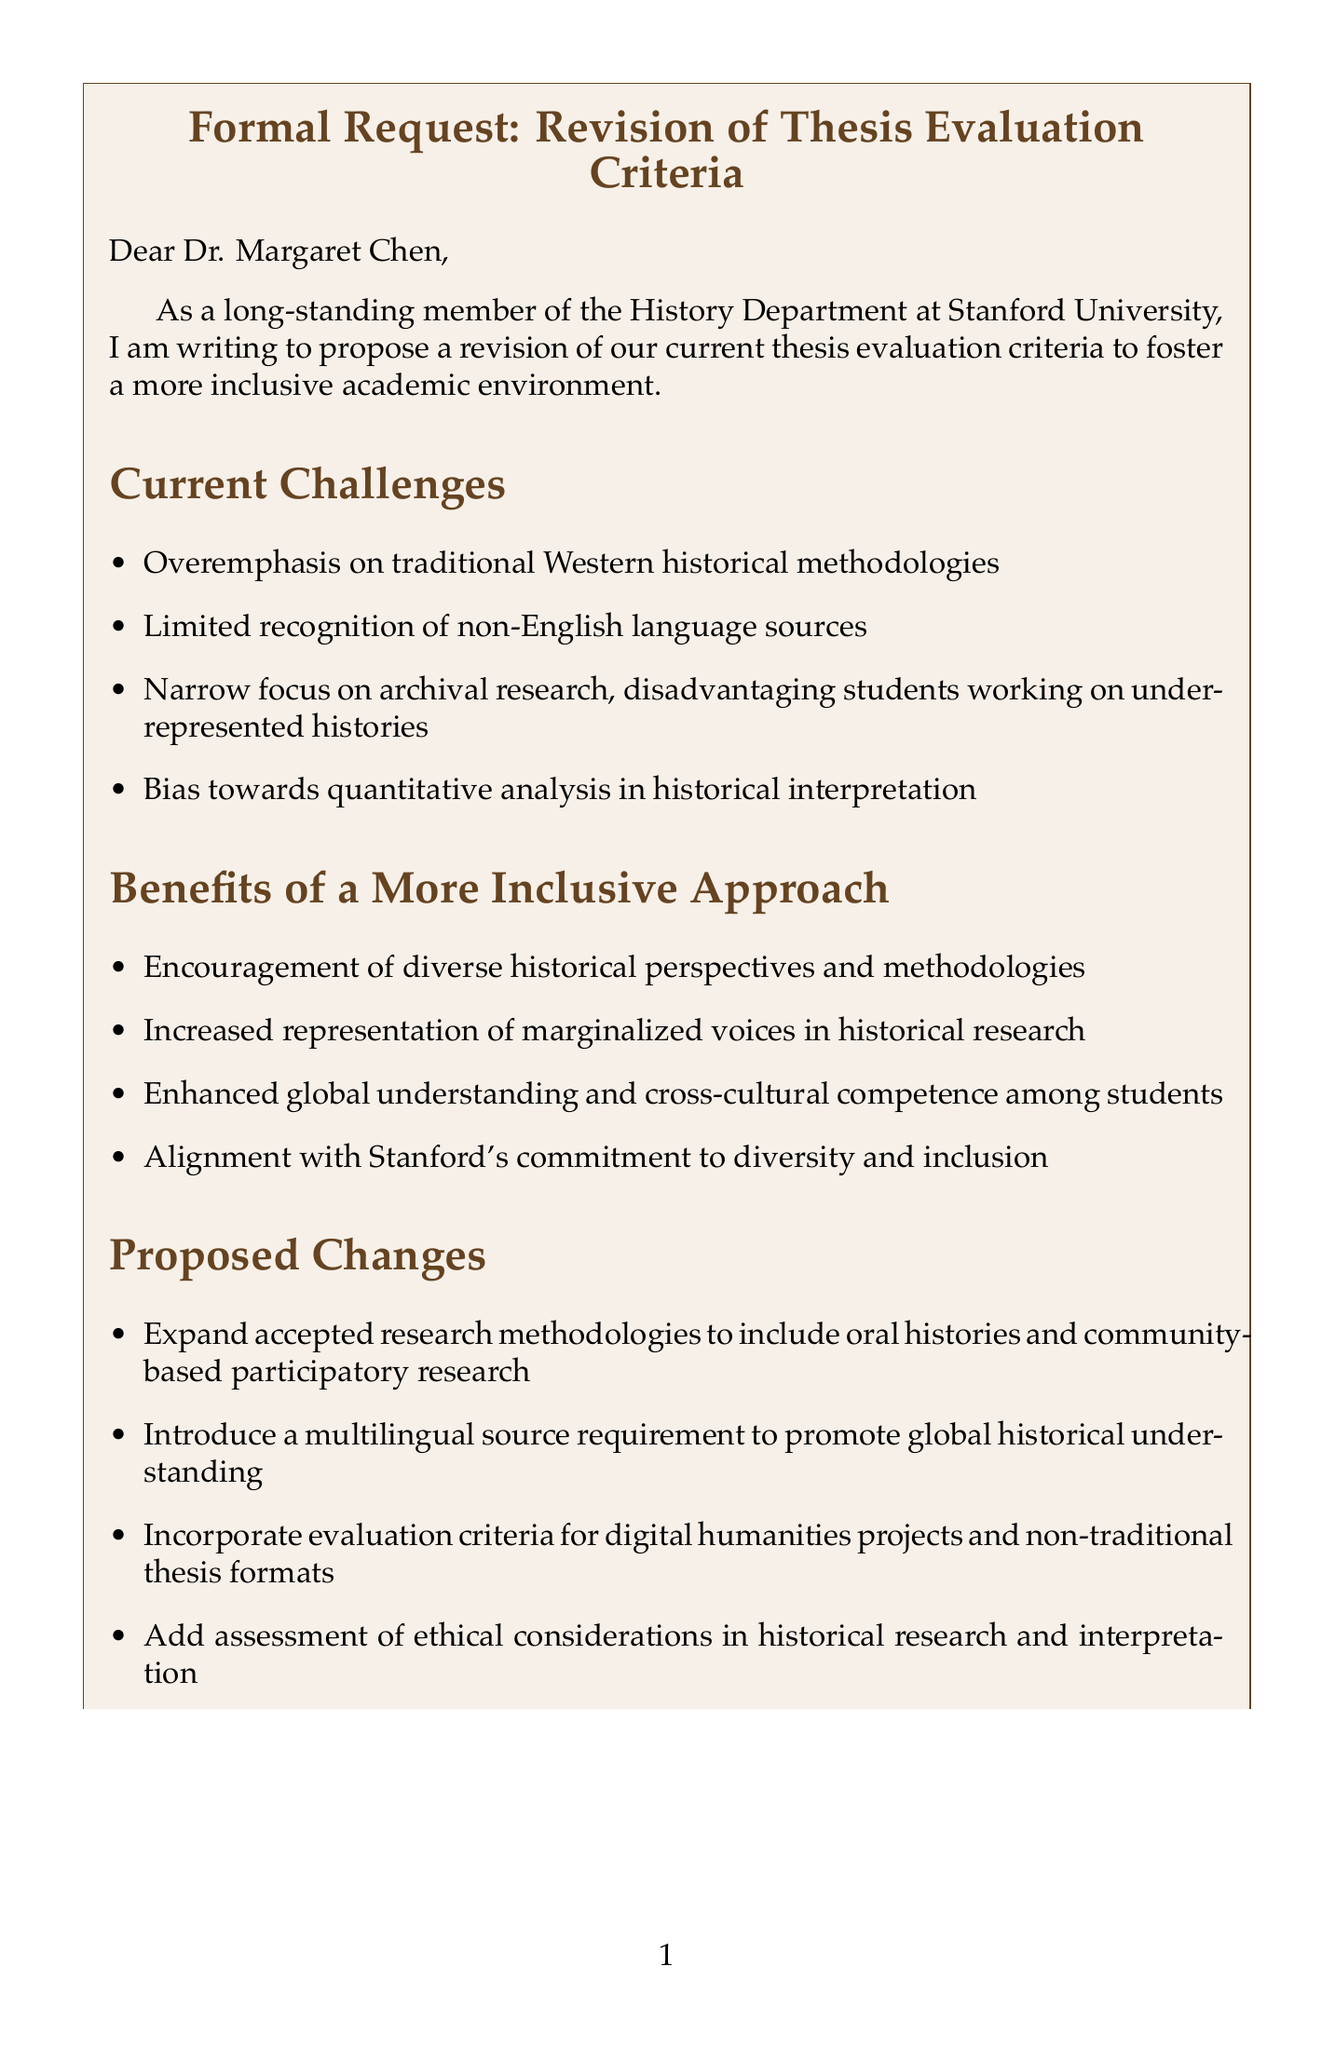What is the salutation of the letter? The salutation introduces the recipient of the letter and is often a formal greeting, in this case it is directed to Dr. Margaret Chen.
Answer: Dear Dr. Margaret Chen, What is one challenge mentioned in the current evaluation criteria? The document lists specific current challenges, one of which points out the overemphasis on a certain type of historical methodology.
Answer: Overemphasis on traditional Western historical methodologies What is one benefit of a more inclusive approach? The letter discusses the advantages of a more inclusive approach, highlighting the representation of marginalized voices.
Answer: Increased representation of marginalized voices in historical research How many phases are included in the implementation plan? The implementation plan details a step-by-step process, which is presented in four distinct phases.
Answer: 4 What is one proposed change to the evaluation criteria? The letter suggests specific modifications to enhance the evaluation criteria, one of which includes expanding the types of research methodologies accepted.
Answer: Expand accepted research methodologies to include oral histories and community-based participatory research What is the main purpose of this letter? The document serves to formally propose revisions in a particular context within an academic setting, focusing on criteria related to thesis evaluations.
Answer: To foster a more inclusive academic environment Which university is mentioned as an example of implementing changes? The letter references other universities to support its proposal, with one example being significant changes made at the University of California, Berkeley.
Answer: University of California, Berkeley What request is made for departmental support? The document outlines multiple logistical requests for cooperation, one of which involves forming a committee for revision purposes.
Answer: Approval to form the revision committee 